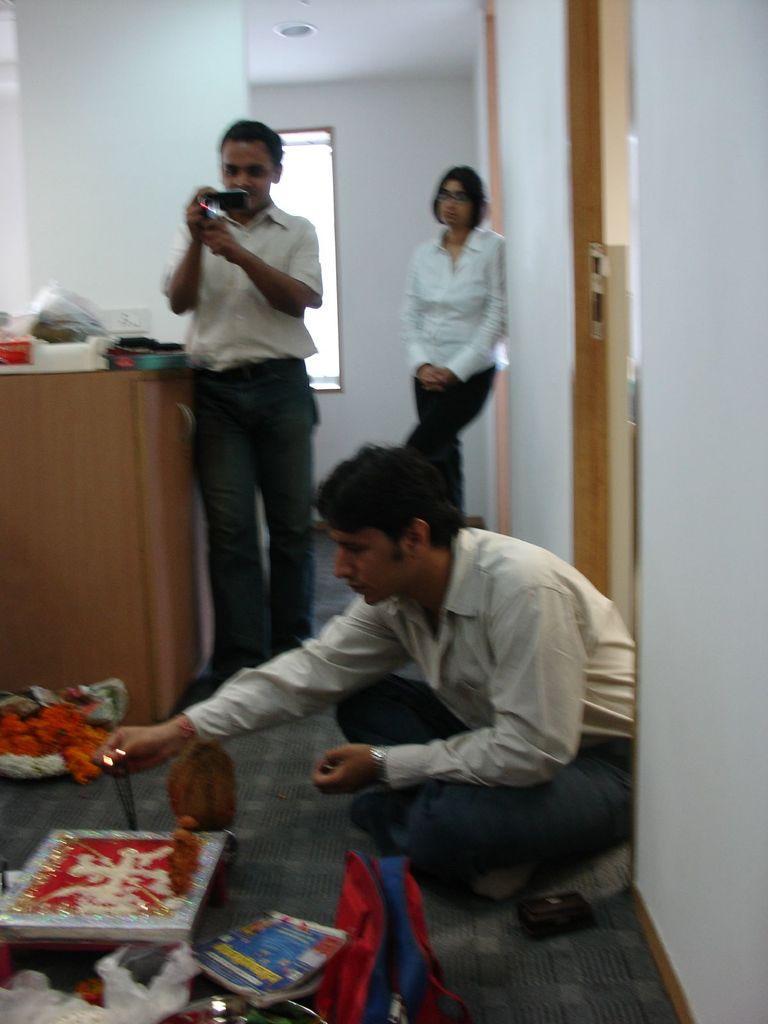Can you describe this image briefly? On the right side a man is sitting on the floor and trying to light the sticks. In the middle a man is standing and shooting with the mobile phone, here a woman is standing she wore a white color shirt. 